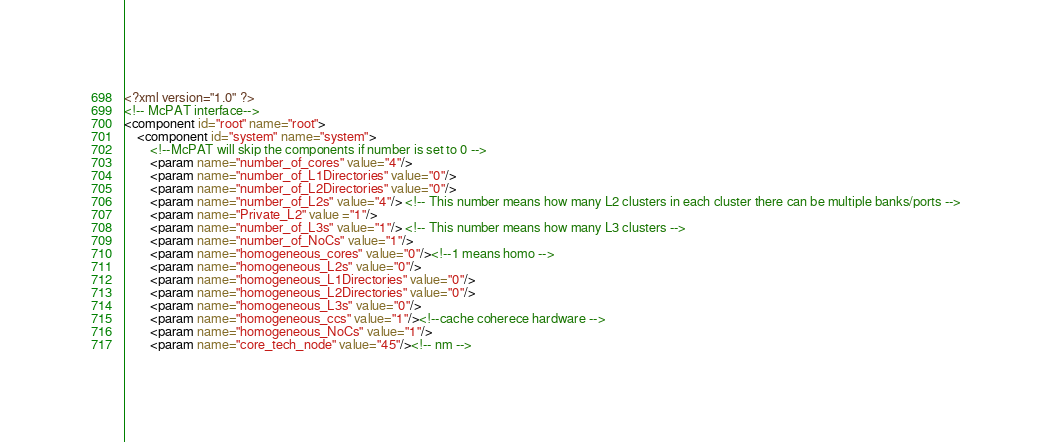<code> <loc_0><loc_0><loc_500><loc_500><_XML_><?xml version="1.0" ?>
<!-- McPAT interface-->
<component id="root" name="root">
	<component id="system" name="system">
		<!--McPAT will skip the components if number is set to 0 -->
		<param name="number_of_cores" value="4"/>
		<param name="number_of_L1Directories" value="0"/>
		<param name="number_of_L2Directories" value="0"/>
		<param name="number_of_L2s" value="4"/> <!-- This number means how many L2 clusters in each cluster there can be multiple banks/ports -->
		<param name="Private_L2" value ="1"/>
		<param name="number_of_L3s" value="1"/> <!-- This number means how many L3 clusters -->
		<param name="number_of_NoCs" value="1"/>
		<param name="homogeneous_cores" value="0"/><!--1 means homo -->
		<param name="homogeneous_L2s" value="0"/>
		<param name="homogeneous_L1Directories" value="0"/>
		<param name="homogeneous_L2Directories" value="0"/>
		<param name="homogeneous_L3s" value="0"/>
		<param name="homogeneous_ccs" value="1"/><!--cache coherece hardware -->
		<param name="homogeneous_NoCs" value="1"/>
		<param name="core_tech_node" value="45"/><!-- nm --></code> 